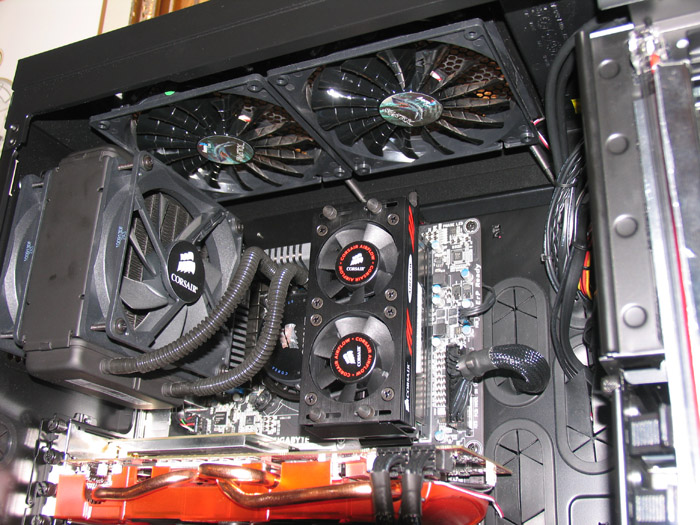What kind of performance can you expect from this setup when playing modern AAA games at maximum settings? With this setup, incorporating a high-end GPU, liquid cooling, and likely a powerful CPU, you can expect exceptional performance when playing modern AAA games at maximum settings. This system should be capable of delivering smooth frame rates, detailed graphics, and a fluid gaming experience, even with demanding titles. The efficient cooling ensures that the system maintains optimal temperatures, preventing throttling and maintaining consistent high performance. 